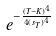Convert formula to latex. <formula><loc_0><loc_0><loc_500><loc_500>e ^ { - \frac { ( T - K ) ^ { 4 } } { 4 { ( s _ { T } ) } ^ { 4 } } }</formula> 